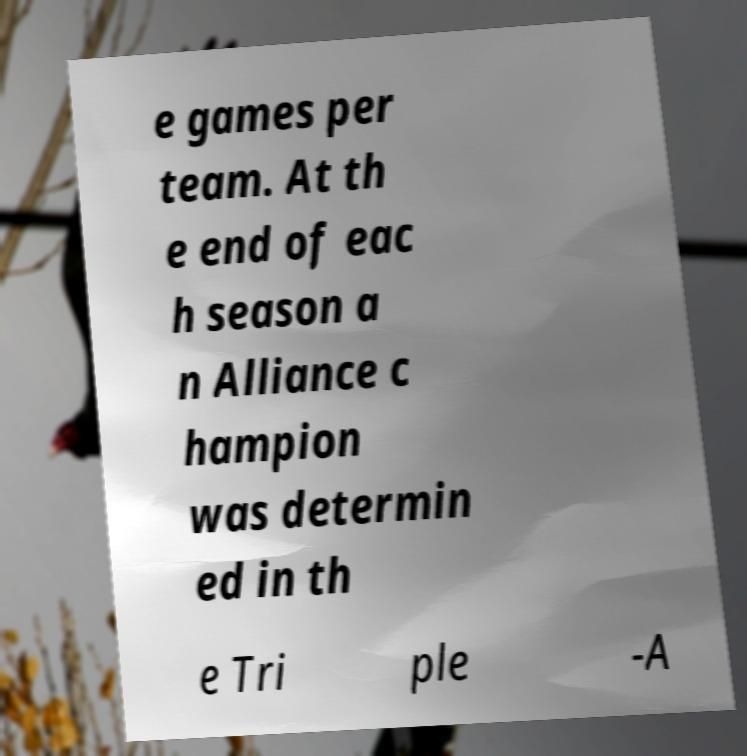There's text embedded in this image that I need extracted. Can you transcribe it verbatim? e games per team. At th e end of eac h season a n Alliance c hampion was determin ed in th e Tri ple -A 